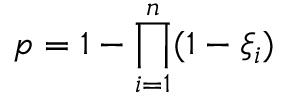<formula> <loc_0><loc_0><loc_500><loc_500>p = 1 - \prod _ { i = 1 } ^ { n } ( 1 - \xi _ { i } )</formula> 